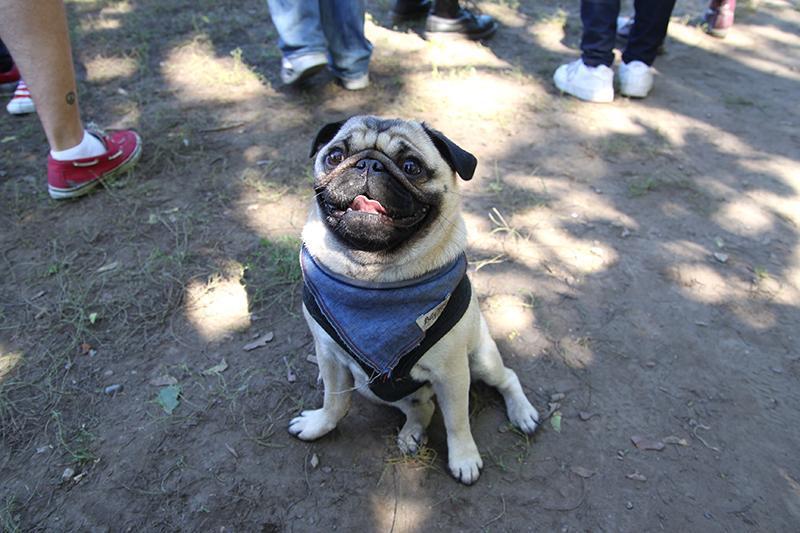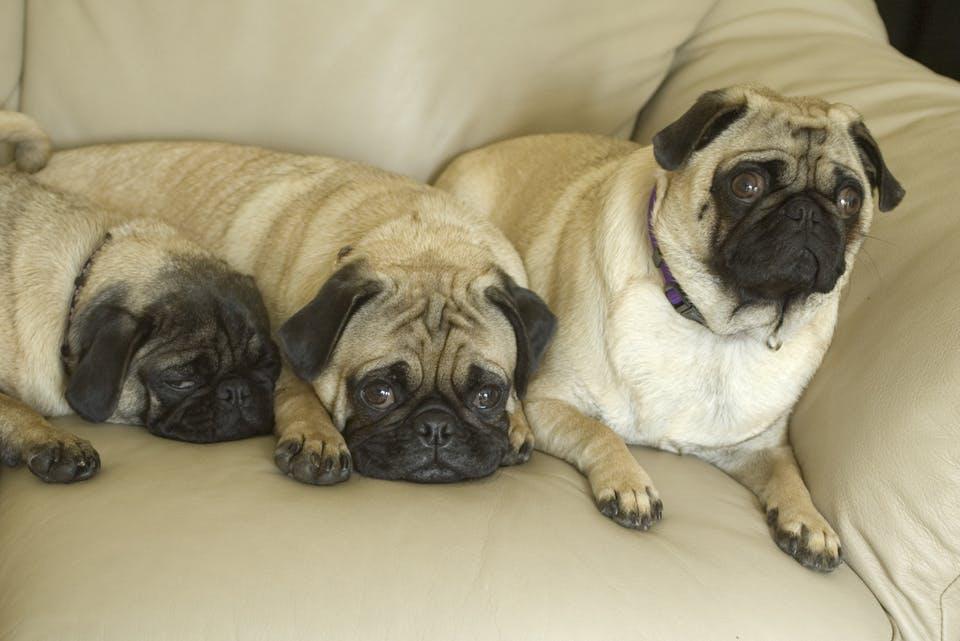The first image is the image on the left, the second image is the image on the right. Analyze the images presented: Is the assertion "At least one of the dogs is near a human." valid? Answer yes or no. Yes. The first image is the image on the left, the second image is the image on the right. Considering the images on both sides, is "The right image contains no more than three dogs." valid? Answer yes or no. Yes. 